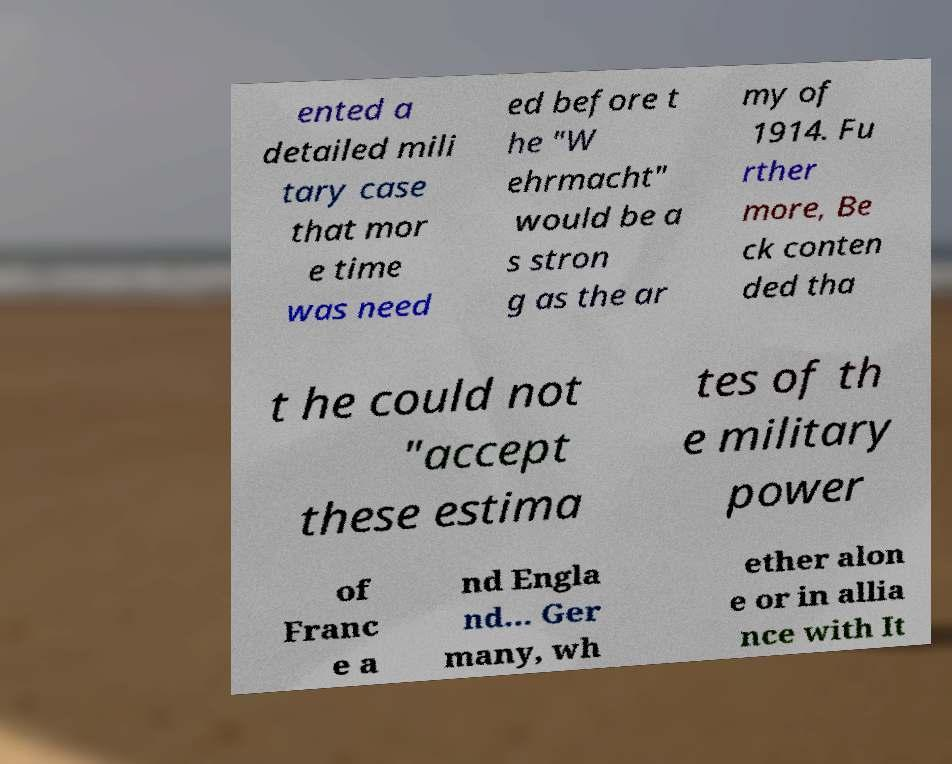Could you extract and type out the text from this image? ented a detailed mili tary case that mor e time was need ed before t he "W ehrmacht" would be a s stron g as the ar my of 1914. Fu rther more, Be ck conten ded tha t he could not "accept these estima tes of th e military power of Franc e a nd Engla nd... Ger many, wh ether alon e or in allia nce with It 